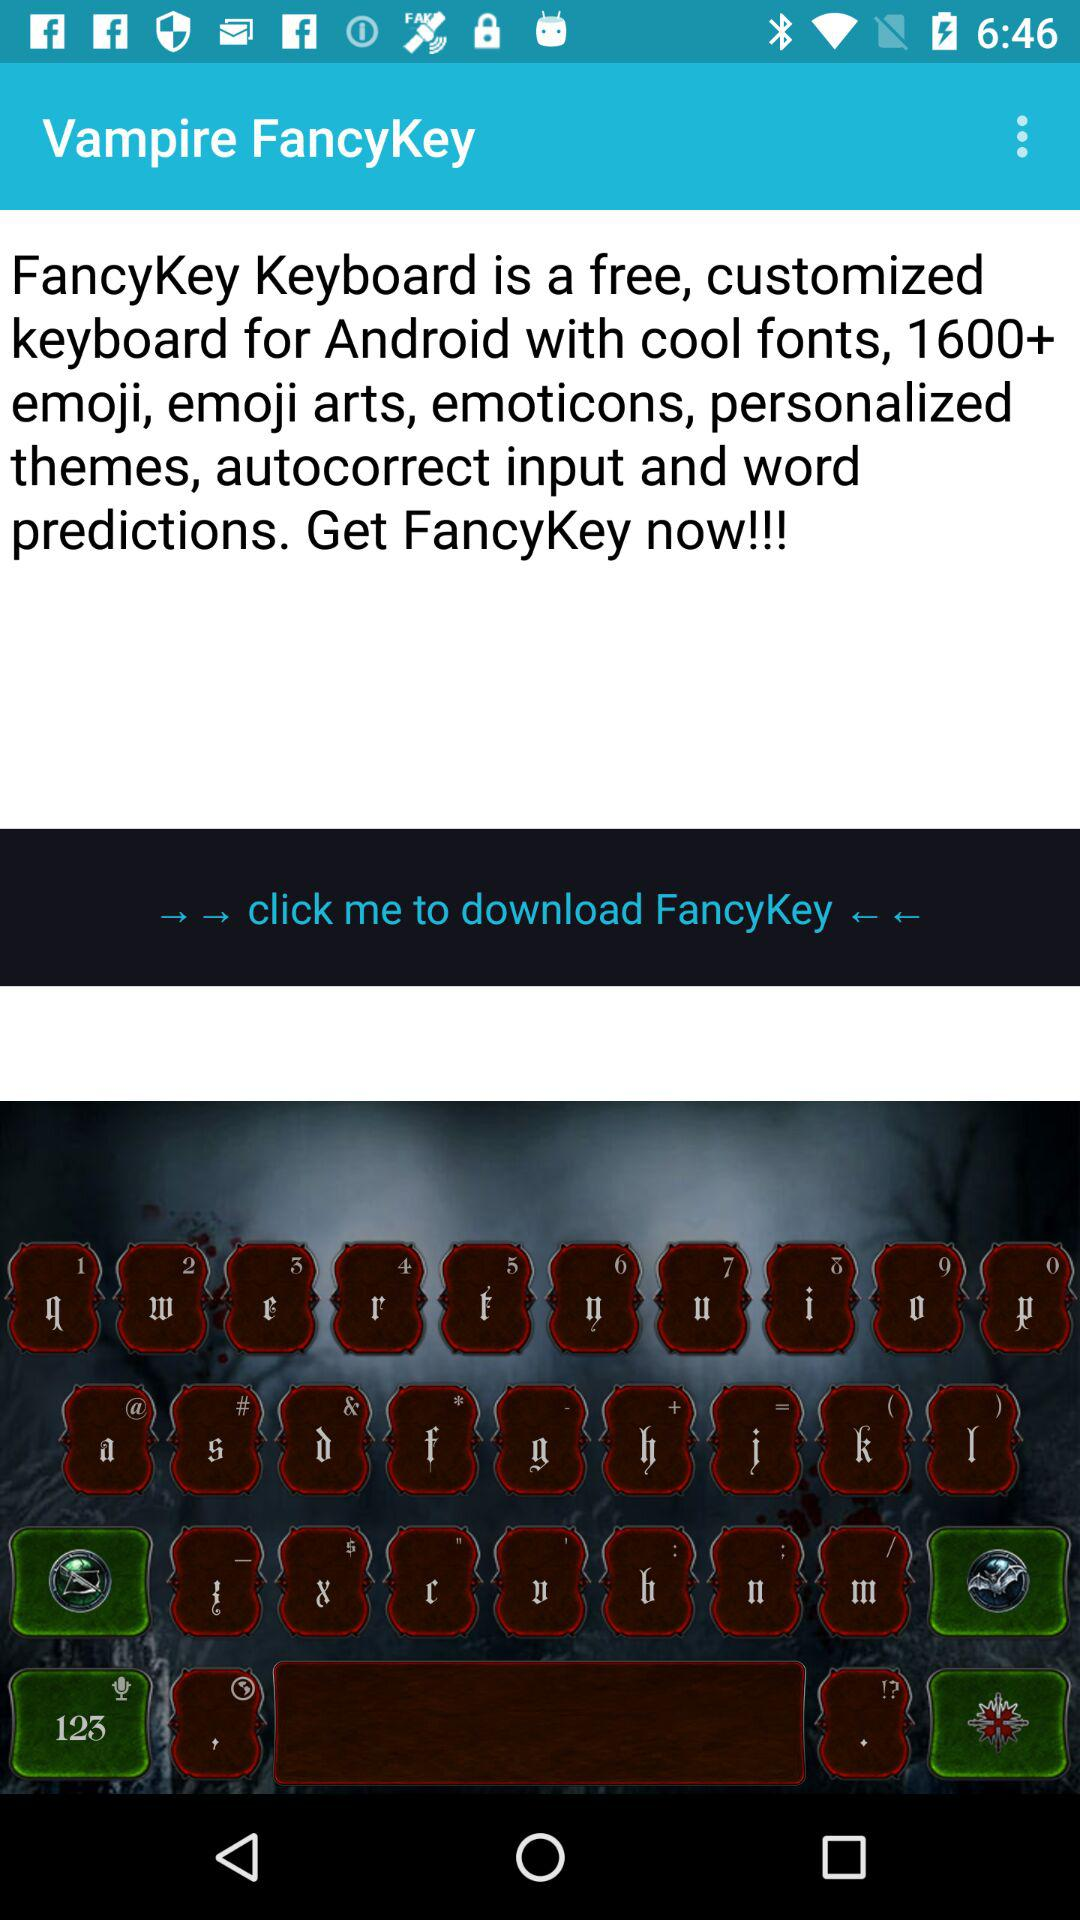What is the application name? The application name is "Vampire FancyKey". 